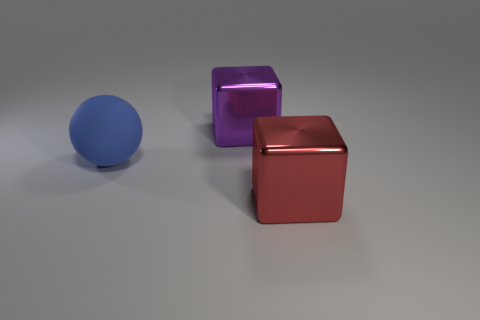Is there a large purple cube that has the same material as the red block?
Offer a terse response. Yes. What number of purple things are cylinders or big metallic blocks?
Provide a succinct answer. 1. Is the number of blue matte things that are in front of the blue rubber ball greater than the number of blue rubber balls?
Your answer should be very brief. No. How many cylinders are big matte objects or big red objects?
Provide a succinct answer. 0. What is the shape of the large object that is both in front of the purple cube and right of the blue matte ball?
Offer a very short reply. Cube. Are there the same number of large red metal cubes to the right of the red metallic thing and blue rubber things that are to the right of the sphere?
Offer a terse response. Yes. What number of things are either big shiny objects or small blue rubber blocks?
Your answer should be compact. 2. What color is the metal thing that is the same size as the purple shiny block?
Keep it short and to the point. Red. How many objects are either big metal things on the right side of the purple shiny thing or things that are behind the blue matte sphere?
Provide a short and direct response. 2. Are there the same number of large red objects that are on the right side of the big red metallic block and tiny purple matte balls?
Keep it short and to the point. Yes. 